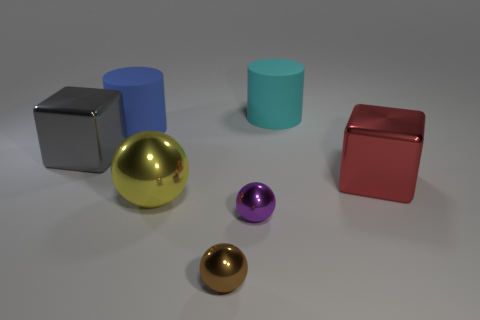Add 1 large things. How many objects exist? 8 Subtract all small balls. How many balls are left? 1 Subtract all yellow balls. How many balls are left? 2 Subtract all spheres. How many objects are left? 4 Subtract 0 cyan blocks. How many objects are left? 7 Subtract 2 balls. How many balls are left? 1 Subtract all purple cylinders. Subtract all cyan cubes. How many cylinders are left? 2 Subtract all big purple metallic things. Subtract all metallic spheres. How many objects are left? 4 Add 6 purple metal objects. How many purple metal objects are left? 7 Add 6 tiny brown metallic objects. How many tiny brown metallic objects exist? 7 